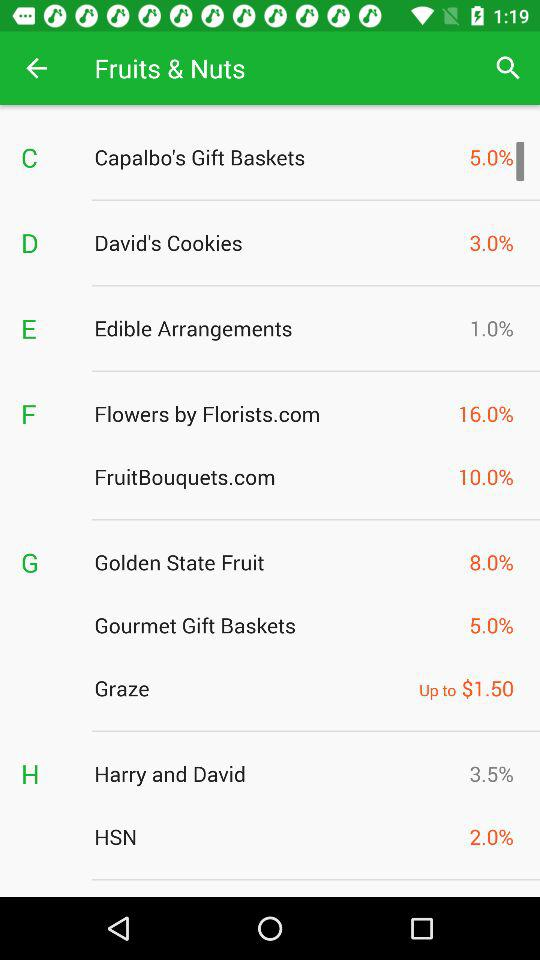How many percent off is the lowest discount?
Answer the question using a single word or phrase. 1.0% 